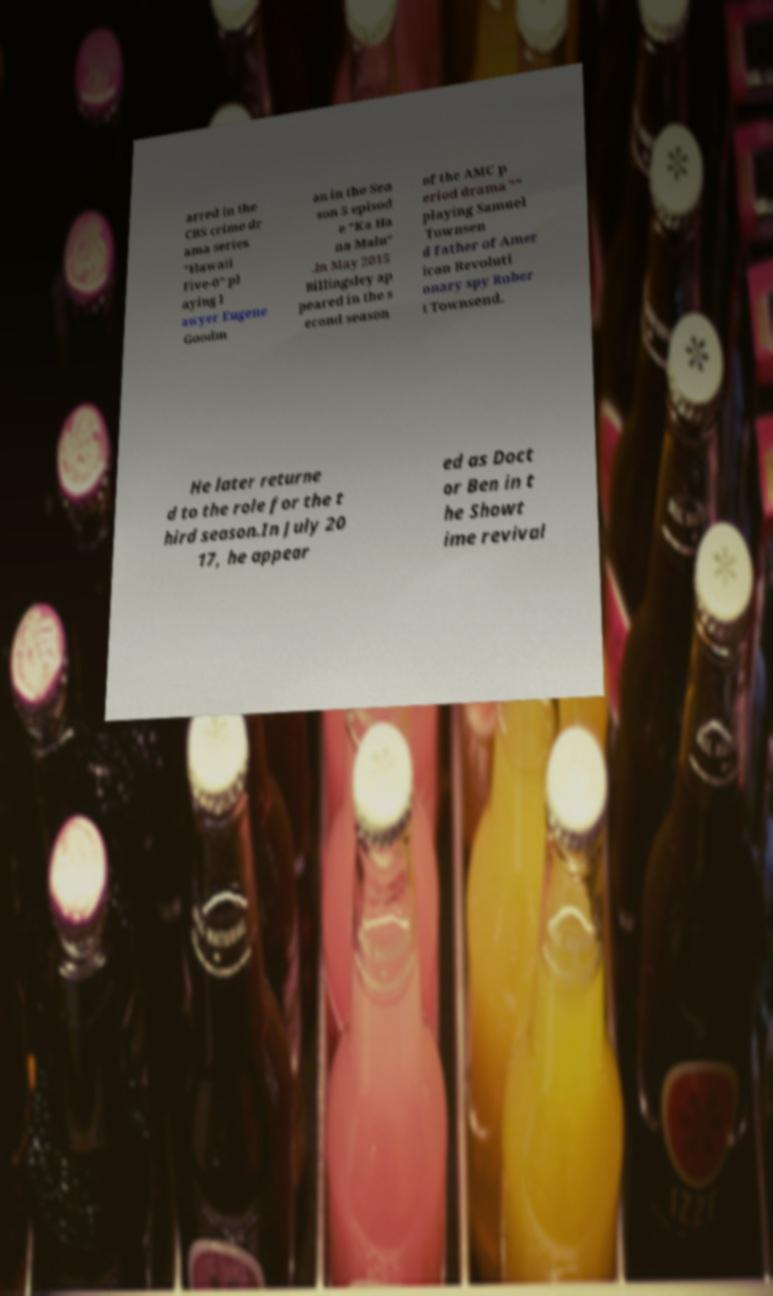Please read and relay the text visible in this image. What does it say? arred in the CBS crime dr ama series "Hawaii Five-0" pl aying l awyer Eugene Goodm an in the Sea son 5 episod e "Ka Ha na Malu" .In May 2015 Billingsley ap peared in the s econd season of the AMC p eriod drama "" playing Samuel Townsen d father of Amer ican Revoluti onary spy Rober t Townsend. He later returne d to the role for the t hird season.In July 20 17, he appear ed as Doct or Ben in t he Showt ime revival 